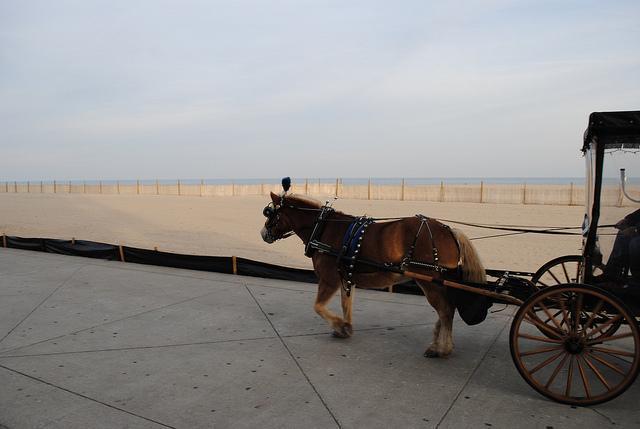How many horses?
Give a very brief answer. 1. How many cars are here?
Give a very brief answer. 0. How many horses are there?
Give a very brief answer. 1. How many propeller airplanes are there?
Give a very brief answer. 0. 